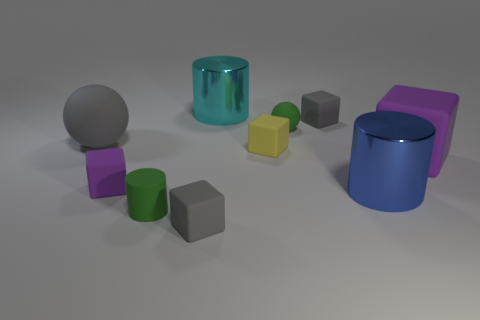How many cyan things are the same shape as the blue thing?
Your response must be concise. 1. What is the cylinder behind the large ball made of?
Give a very brief answer. Metal. There is a purple matte object that is on the left side of the large blue thing; does it have the same shape as the large cyan thing?
Make the answer very short. No. Are there any purple matte objects of the same size as the blue cylinder?
Your answer should be very brief. Yes. Do the yellow rubber object and the shiny object in front of the large purple block have the same shape?
Provide a short and direct response. No. What is the shape of the small thing that is the same color as the small rubber sphere?
Your answer should be very brief. Cylinder. Is the number of small matte cylinders in front of the large gray thing less than the number of large gray rubber things?
Provide a short and direct response. No. Does the big gray thing have the same shape as the tiny yellow thing?
Offer a terse response. No. There is a green cylinder that is made of the same material as the big gray sphere; what size is it?
Keep it short and to the point. Small. Are there fewer large blue metal objects than large green matte cylinders?
Keep it short and to the point. No. 